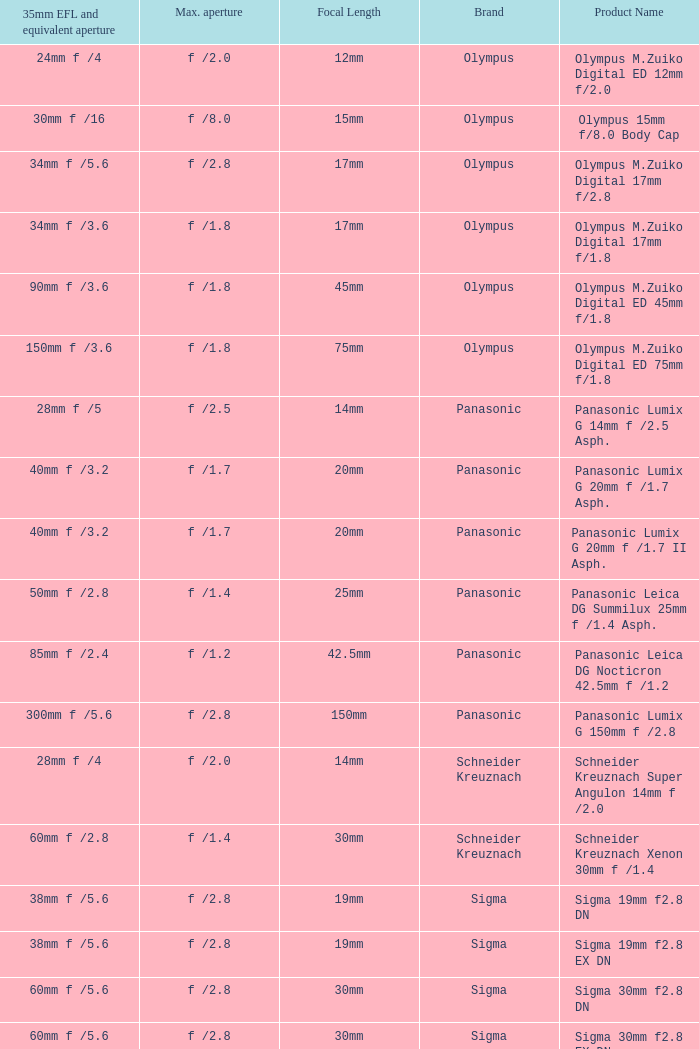What is the brand of the Sigma 30mm f2.8 DN, which has a maximum aperture of f /2.8 and a focal length of 30mm? Sigma. 